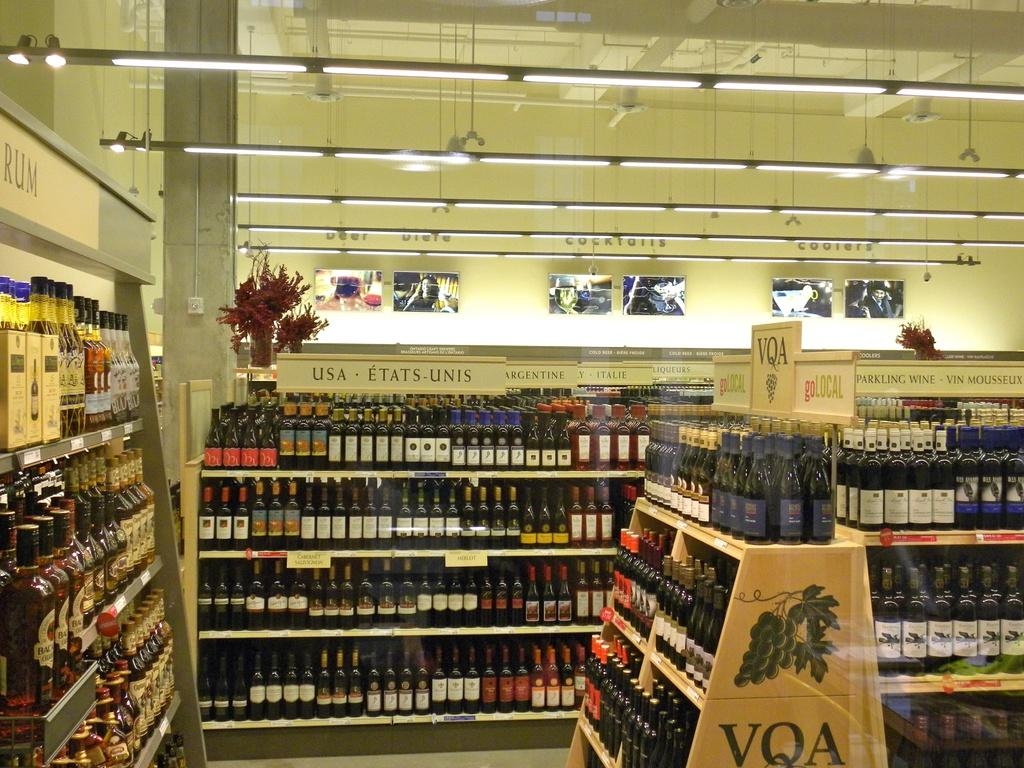<image>
Share a concise interpretation of the image provided. The liquor store has wine from the USA, Argentina, and Italy. 